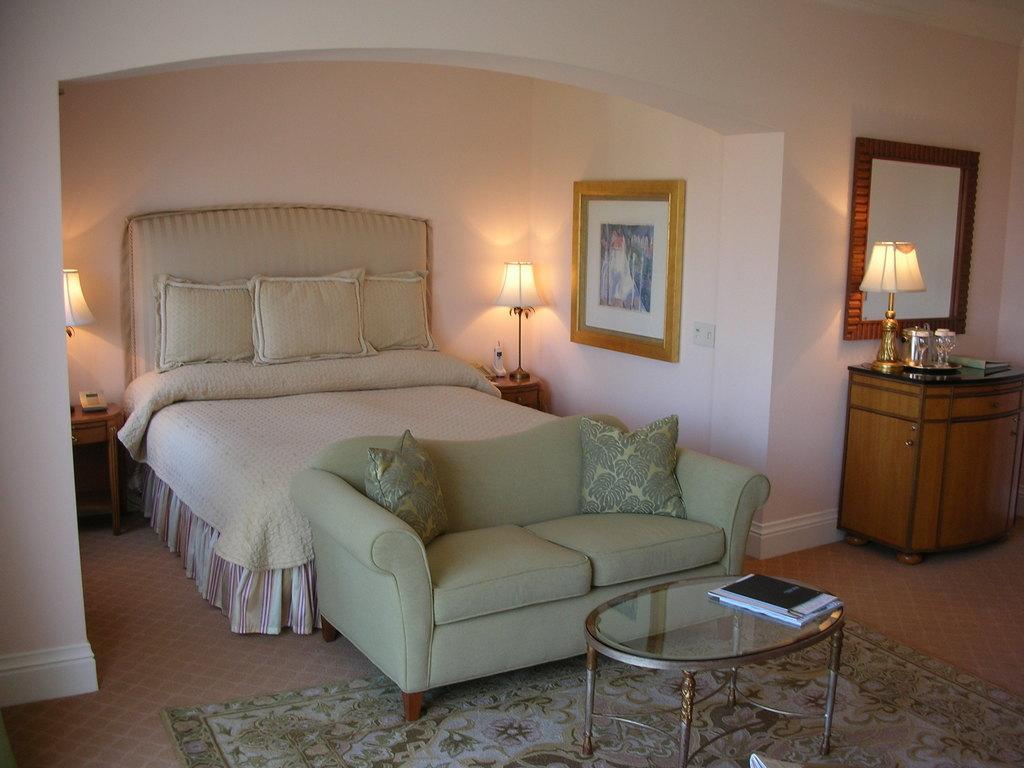In one or two sentences, can you explain what this image depicts? A bedroom is shown in the picture. It has a bed with three pillows,two lamps on either side,a photo frame on wall,sofa in front,a table and a cup board with lamp on it. 